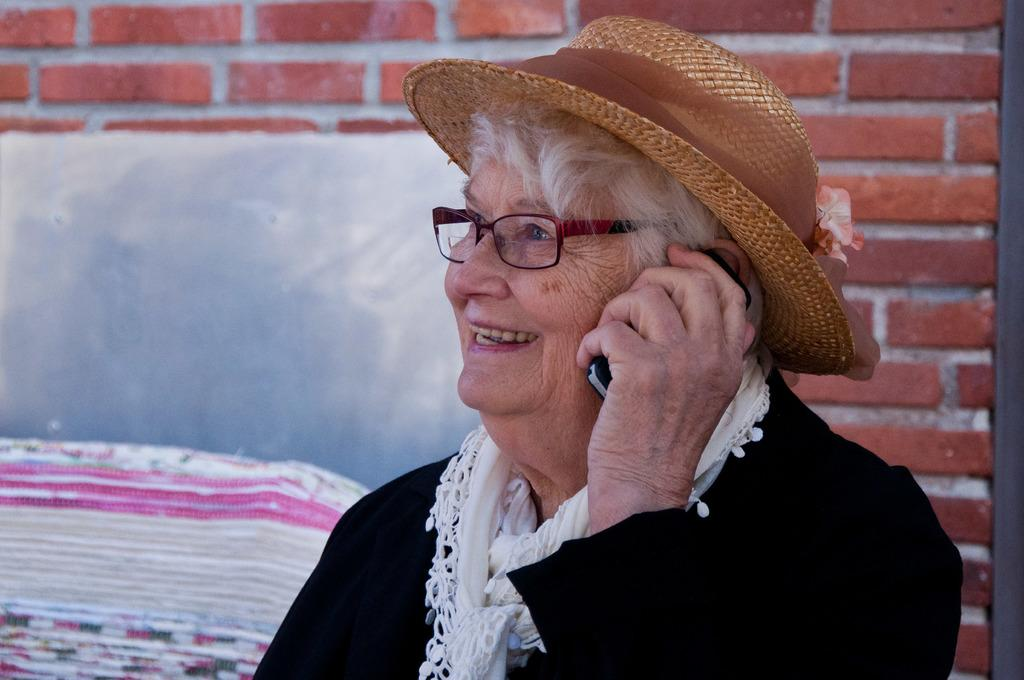Who is present in the image? There is a woman in the image. What is the woman wearing on her head? The woman is wearing a cap. What is the woman wearing on her face? The woman is wearing spectacles. What object is the woman holding in her hand? The woman is holding a mobile. What expression does the woman have on her face? The woman is smiling. What can be seen in the background of the image? There is a wall in the background of the image. What type of pollution can be seen in the image? There is no pollution visible in the image; it features a woman wearing a cap, spectacles, and a smile, holding a mobile, and standing in front of a wall. 